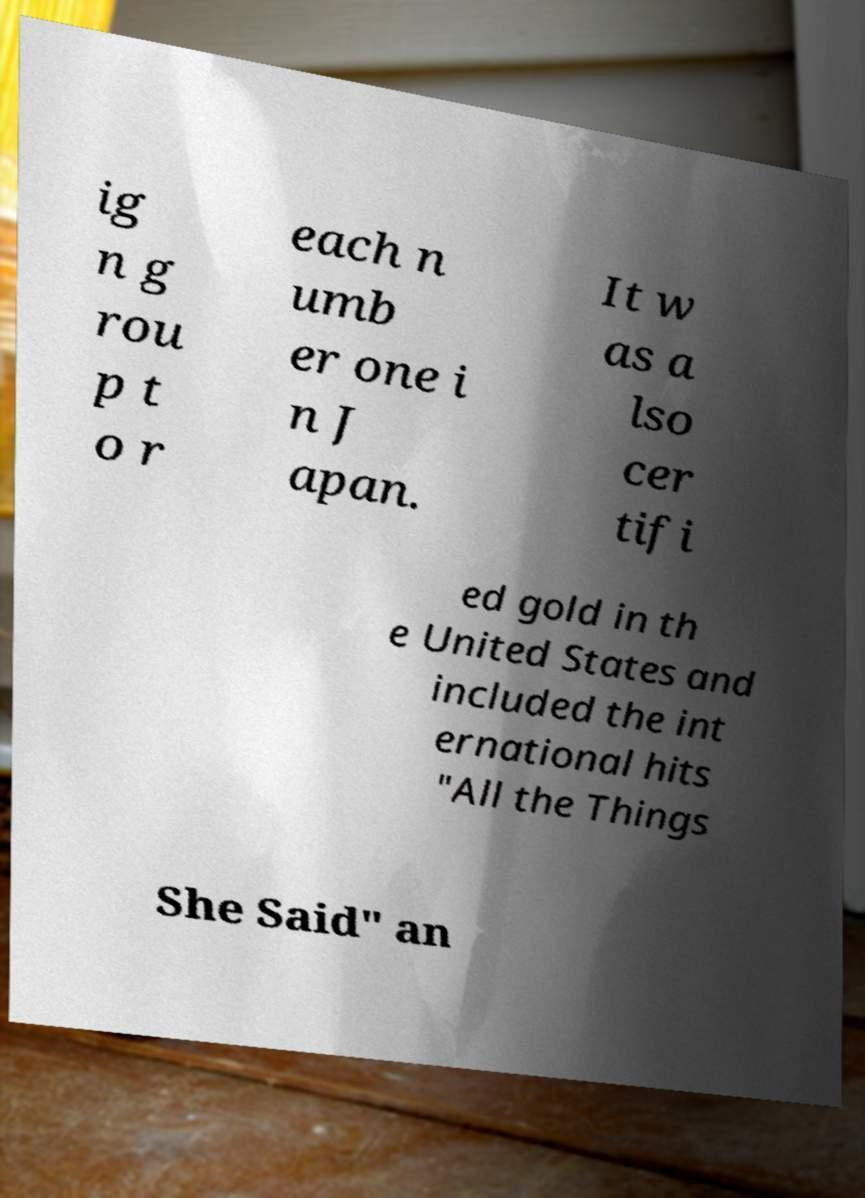Could you assist in decoding the text presented in this image and type it out clearly? ig n g rou p t o r each n umb er one i n J apan. It w as a lso cer tifi ed gold in th e United States and included the int ernational hits "All the Things She Said" an 